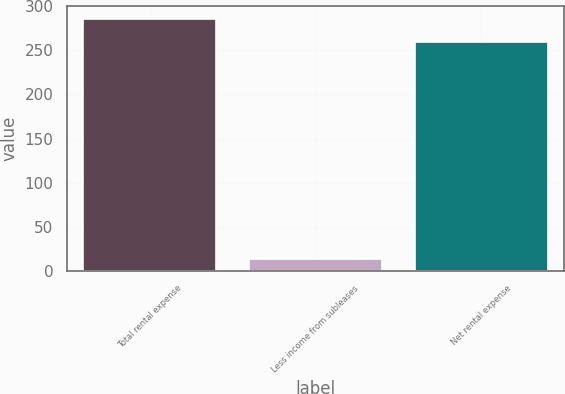<chart> <loc_0><loc_0><loc_500><loc_500><bar_chart><fcel>Total rental expense<fcel>Less income from subleases<fcel>Net rental expense<nl><fcel>286<fcel>13<fcel>260<nl></chart> 